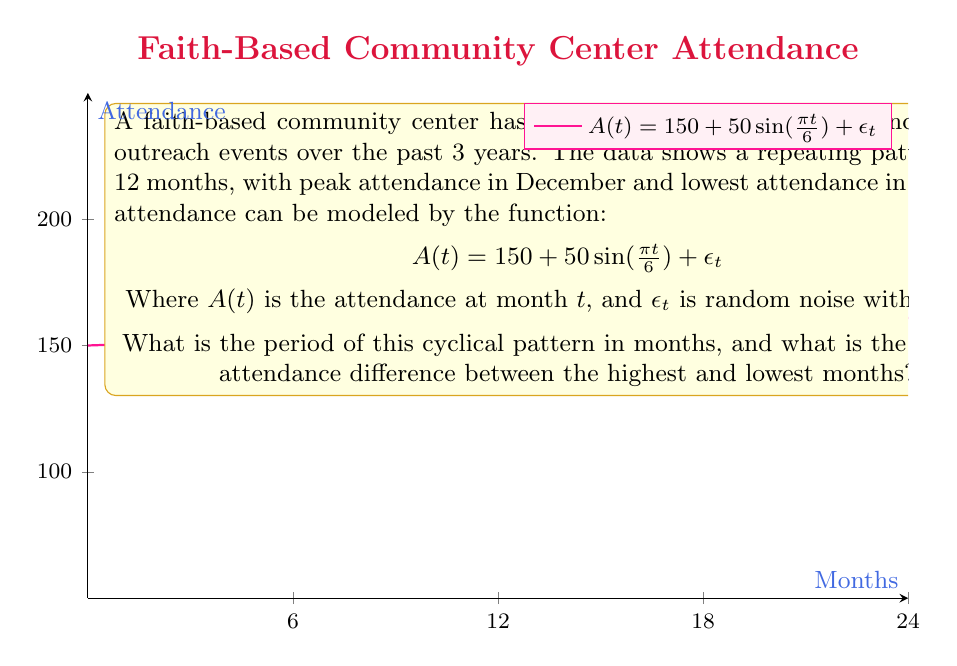Solve this math problem. To solve this problem, we need to analyze the given function and understand its components:

1. Identify the period:
   The sine function in the model is $\sin(\frac{\pi t}{6})$. For a general sine function $\sin(bx)$, the period is given by $\frac{2\pi}{|b|}$.
   Here, $b = \frac{\pi}{6}$
   So, the period = $\frac{2\pi}{|\frac{\pi}{6}|} = 12$ months

2. Calculate the attendance difference:
   The amplitude of the sine wave determines the difference between peak and trough.
   Amplitude = 50 (coefficient of the sine term)
   Peak attendance = 150 + 50 = 200
   Lowest attendance = 150 - 50 = 100
   Difference = 200 - 100 = 100

Note that the random noise term $\epsilon_t$ has a mean of 0, so it doesn't affect the expected attendance difference.
Answer: Period: 12 months; Expected attendance difference: 100 